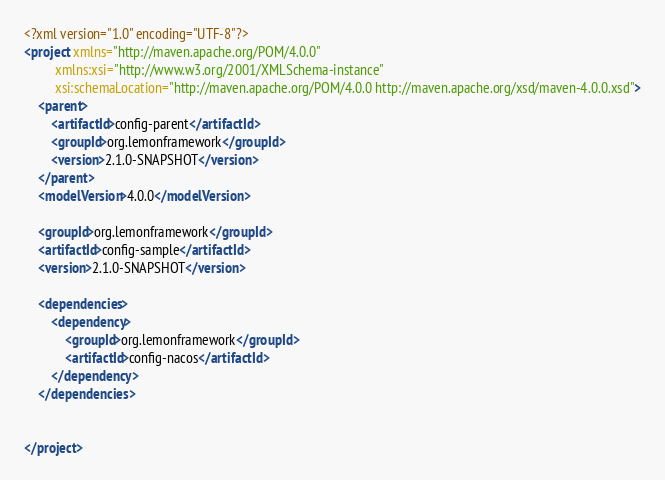<code> <loc_0><loc_0><loc_500><loc_500><_XML_><?xml version="1.0" encoding="UTF-8"?>
<project xmlns="http://maven.apache.org/POM/4.0.0"
         xmlns:xsi="http://www.w3.org/2001/XMLSchema-instance"
         xsi:schemaLocation="http://maven.apache.org/POM/4.0.0 http://maven.apache.org/xsd/maven-4.0.0.xsd">
    <parent>
        <artifactId>config-parent</artifactId>
        <groupId>org.lemonframework</groupId>
        <version>2.1.0-SNAPSHOT</version>
    </parent>
    <modelVersion>4.0.0</modelVersion>

    <groupId>org.lemonframework</groupId>
    <artifactId>config-sample</artifactId>
    <version>2.1.0-SNAPSHOT</version>

    <dependencies>
        <dependency>
            <groupId>org.lemonframework</groupId>
            <artifactId>config-nacos</artifactId>
        </dependency>
    </dependencies>


</project></code> 